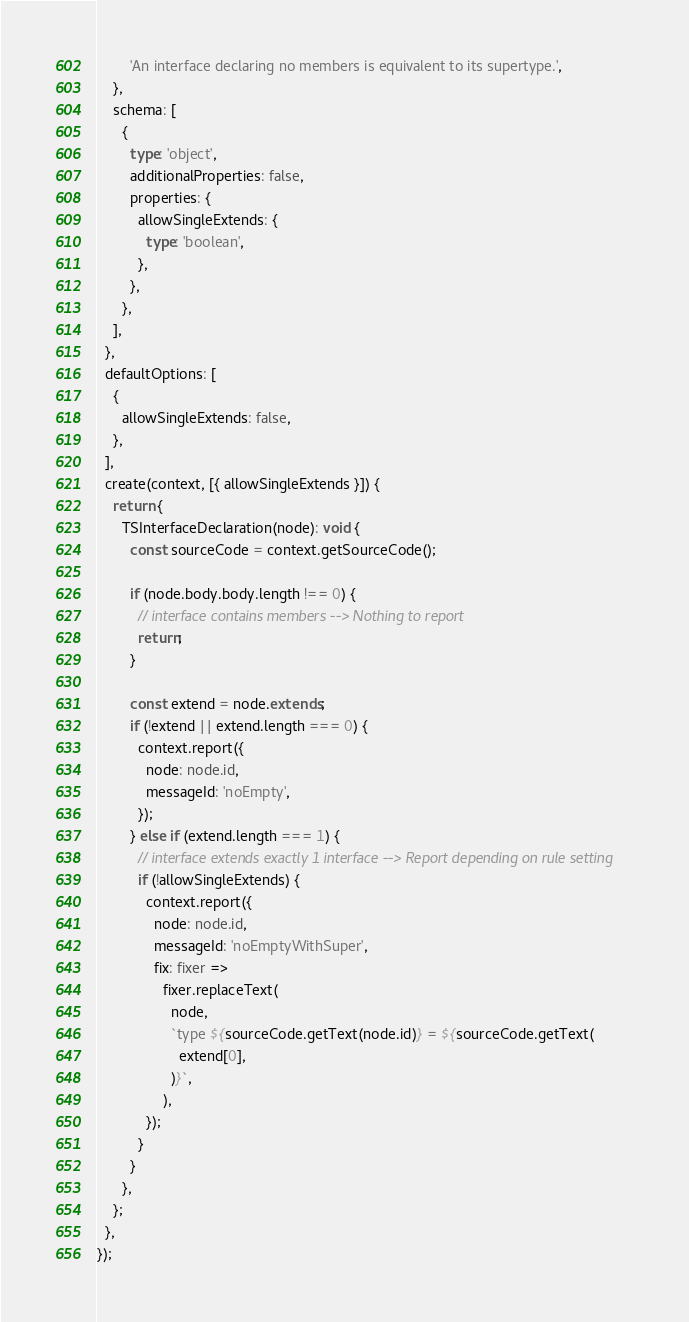<code> <loc_0><loc_0><loc_500><loc_500><_TypeScript_>        'An interface declaring no members is equivalent to its supertype.',
    },
    schema: [
      {
        type: 'object',
        additionalProperties: false,
        properties: {
          allowSingleExtends: {
            type: 'boolean',
          },
        },
      },
    ],
  },
  defaultOptions: [
    {
      allowSingleExtends: false,
    },
  ],
  create(context, [{ allowSingleExtends }]) {
    return {
      TSInterfaceDeclaration(node): void {
        const sourceCode = context.getSourceCode();

        if (node.body.body.length !== 0) {
          // interface contains members --> Nothing to report
          return;
        }

        const extend = node.extends;
        if (!extend || extend.length === 0) {
          context.report({
            node: node.id,
            messageId: 'noEmpty',
          });
        } else if (extend.length === 1) {
          // interface extends exactly 1 interface --> Report depending on rule setting
          if (!allowSingleExtends) {
            context.report({
              node: node.id,
              messageId: 'noEmptyWithSuper',
              fix: fixer =>
                fixer.replaceText(
                  node,
                  `type ${sourceCode.getText(node.id)} = ${sourceCode.getText(
                    extend[0],
                  )}`,
                ),
            });
          }
        }
      },
    };
  },
});
</code> 